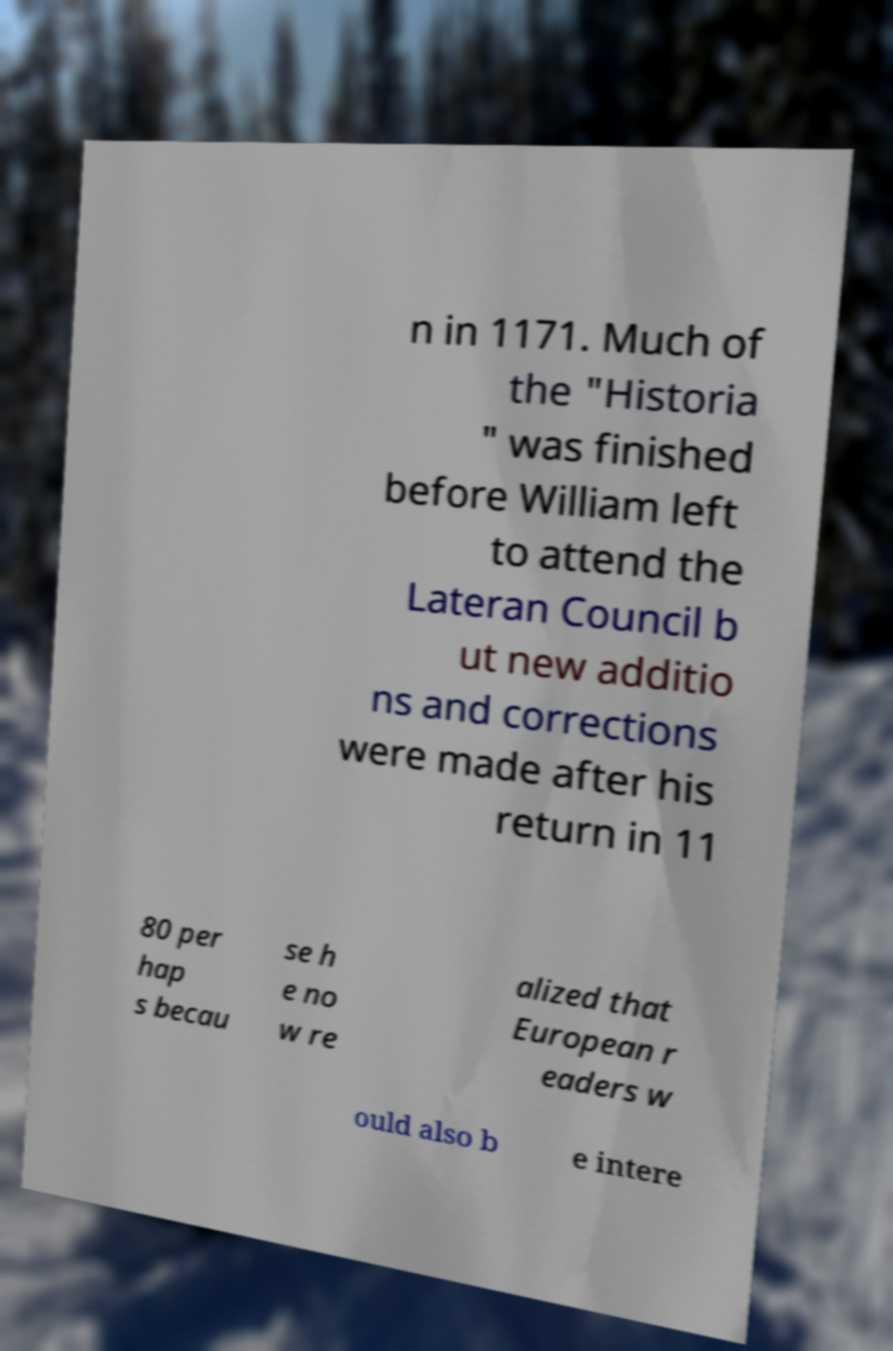For documentation purposes, I need the text within this image transcribed. Could you provide that? n in 1171. Much of the "Historia " was finished before William left to attend the Lateran Council b ut new additio ns and corrections were made after his return in 11 80 per hap s becau se h e no w re alized that European r eaders w ould also b e intere 